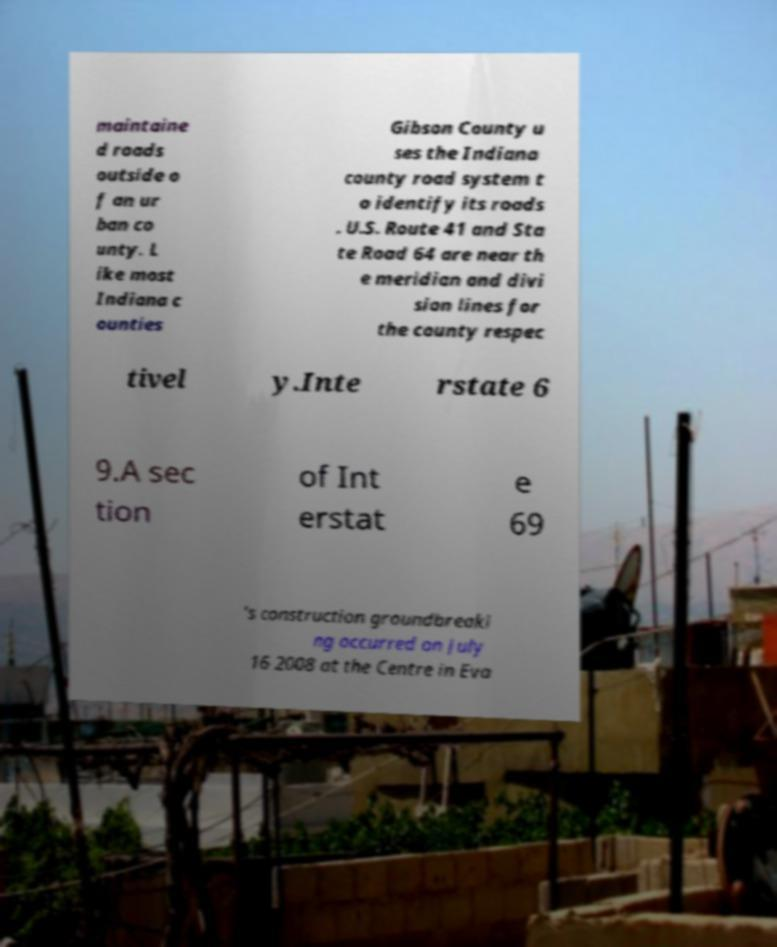For documentation purposes, I need the text within this image transcribed. Could you provide that? maintaine d roads outside o f an ur ban co unty. L ike most Indiana c ounties Gibson County u ses the Indiana county road system t o identify its roads . U.S. Route 41 and Sta te Road 64 are near th e meridian and divi sion lines for the county respec tivel y.Inte rstate 6 9.A sec tion of Int erstat e 69 's construction groundbreaki ng occurred on July 16 2008 at the Centre in Eva 